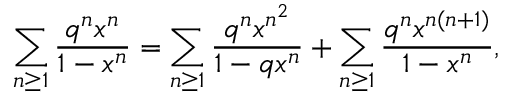Convert formula to latex. <formula><loc_0><loc_0><loc_500><loc_500>\sum _ { n \geq 1 } { \frac { q ^ { n } x ^ { n } } { 1 - x ^ { n } } } = \sum _ { n \geq 1 } { \frac { q ^ { n } x ^ { n ^ { 2 } } } { 1 - q x ^ { n } } } + \sum _ { n \geq 1 } { \frac { q ^ { n } x ^ { n ( n + 1 ) } } { 1 - x ^ { n } } } ,</formula> 